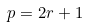Convert formula to latex. <formula><loc_0><loc_0><loc_500><loc_500>p = 2 r + 1</formula> 